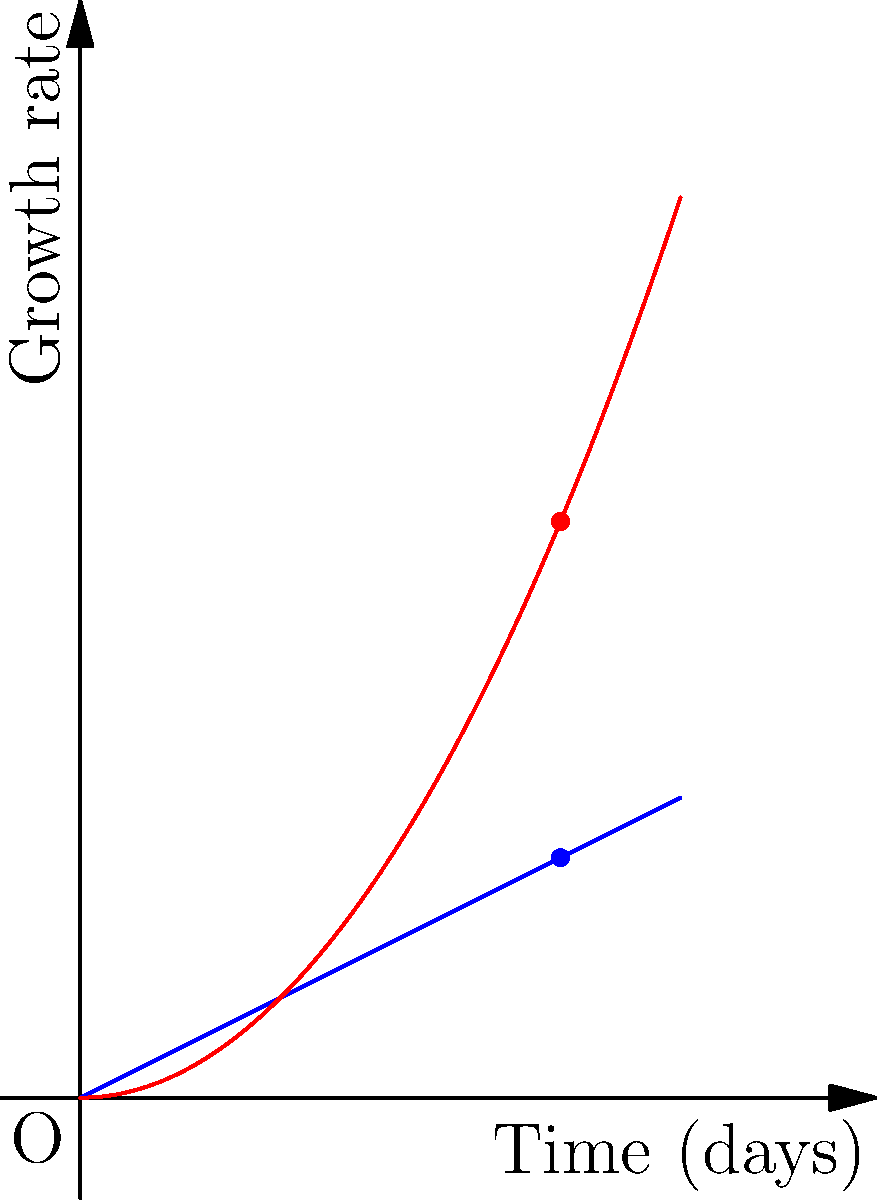In a criminal investigation, you're analyzing the growth rates of two insect species found on a body. Species A exhibits a linear growth rate represented by the vector $\mathbf{a} = (4, 2)$, while Species B shows a quadratic growth rate represented by the vector $\mathbf{b} = (4, 4.8)$ after 4 days. What is the angle between these two vectors, representing the difference in their growth patterns? To find the angle between two vectors, we can use the dot product formula:

$$\cos \theta = \frac{\mathbf{a} \cdot \mathbf{b}}{|\mathbf{a}||\mathbf{b}|}$$

Step 1: Calculate the dot product $\mathbf{a} \cdot \mathbf{b}$
$\mathbf{a} \cdot \mathbf{b} = (4)(4) + (2)(4.8) = 16 + 9.6 = 25.6$

Step 2: Calculate the magnitudes of the vectors
$|\mathbf{a}| = \sqrt{4^2 + 2^2} = \sqrt{20} = 2\sqrt{5}$
$|\mathbf{b}| = \sqrt{4^2 + 4.8^2} = \sqrt{16 + 23.04} = \sqrt{39.04} = 6.25$

Step 3: Apply the formula
$$\cos \theta = \frac{25.6}{(2\sqrt{5})(6.25)} = \frac{25.6}{12.5\sqrt{5}} = \frac{2.048}{\sqrt{5}} = 0.9158$$

Step 4: Take the inverse cosine (arccos) to find the angle
$$\theta = \arccos(0.9158) = 0.4115 \text{ radians}$$

Step 5: Convert to degrees
$$\theta = 0.4115 \times \frac{180^{\circ}}{\pi} = 23.58^{\circ}$$
Answer: $23.58^{\circ}$ 